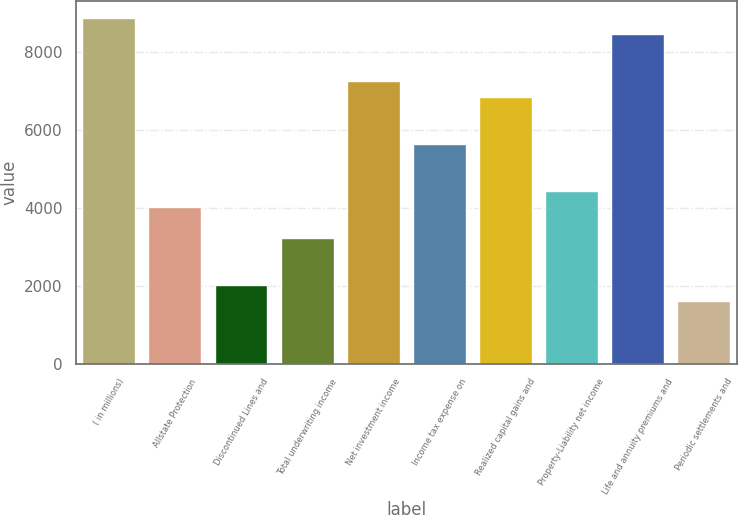Convert chart. <chart><loc_0><loc_0><loc_500><loc_500><bar_chart><fcel>( in millions)<fcel>Allstate Protection<fcel>Discontinued Lines and<fcel>Total underwriting income<fcel>Net investment income<fcel>Income tax expense on<fcel>Realized capital gains and<fcel>Property-Liability net income<fcel>Life and annuity premiums and<fcel>Periodic settlements and<nl><fcel>8862.6<fcel>4029<fcel>2015<fcel>3223.4<fcel>7251.4<fcel>5640.2<fcel>6848.6<fcel>4431.8<fcel>8459.8<fcel>1612.2<nl></chart> 